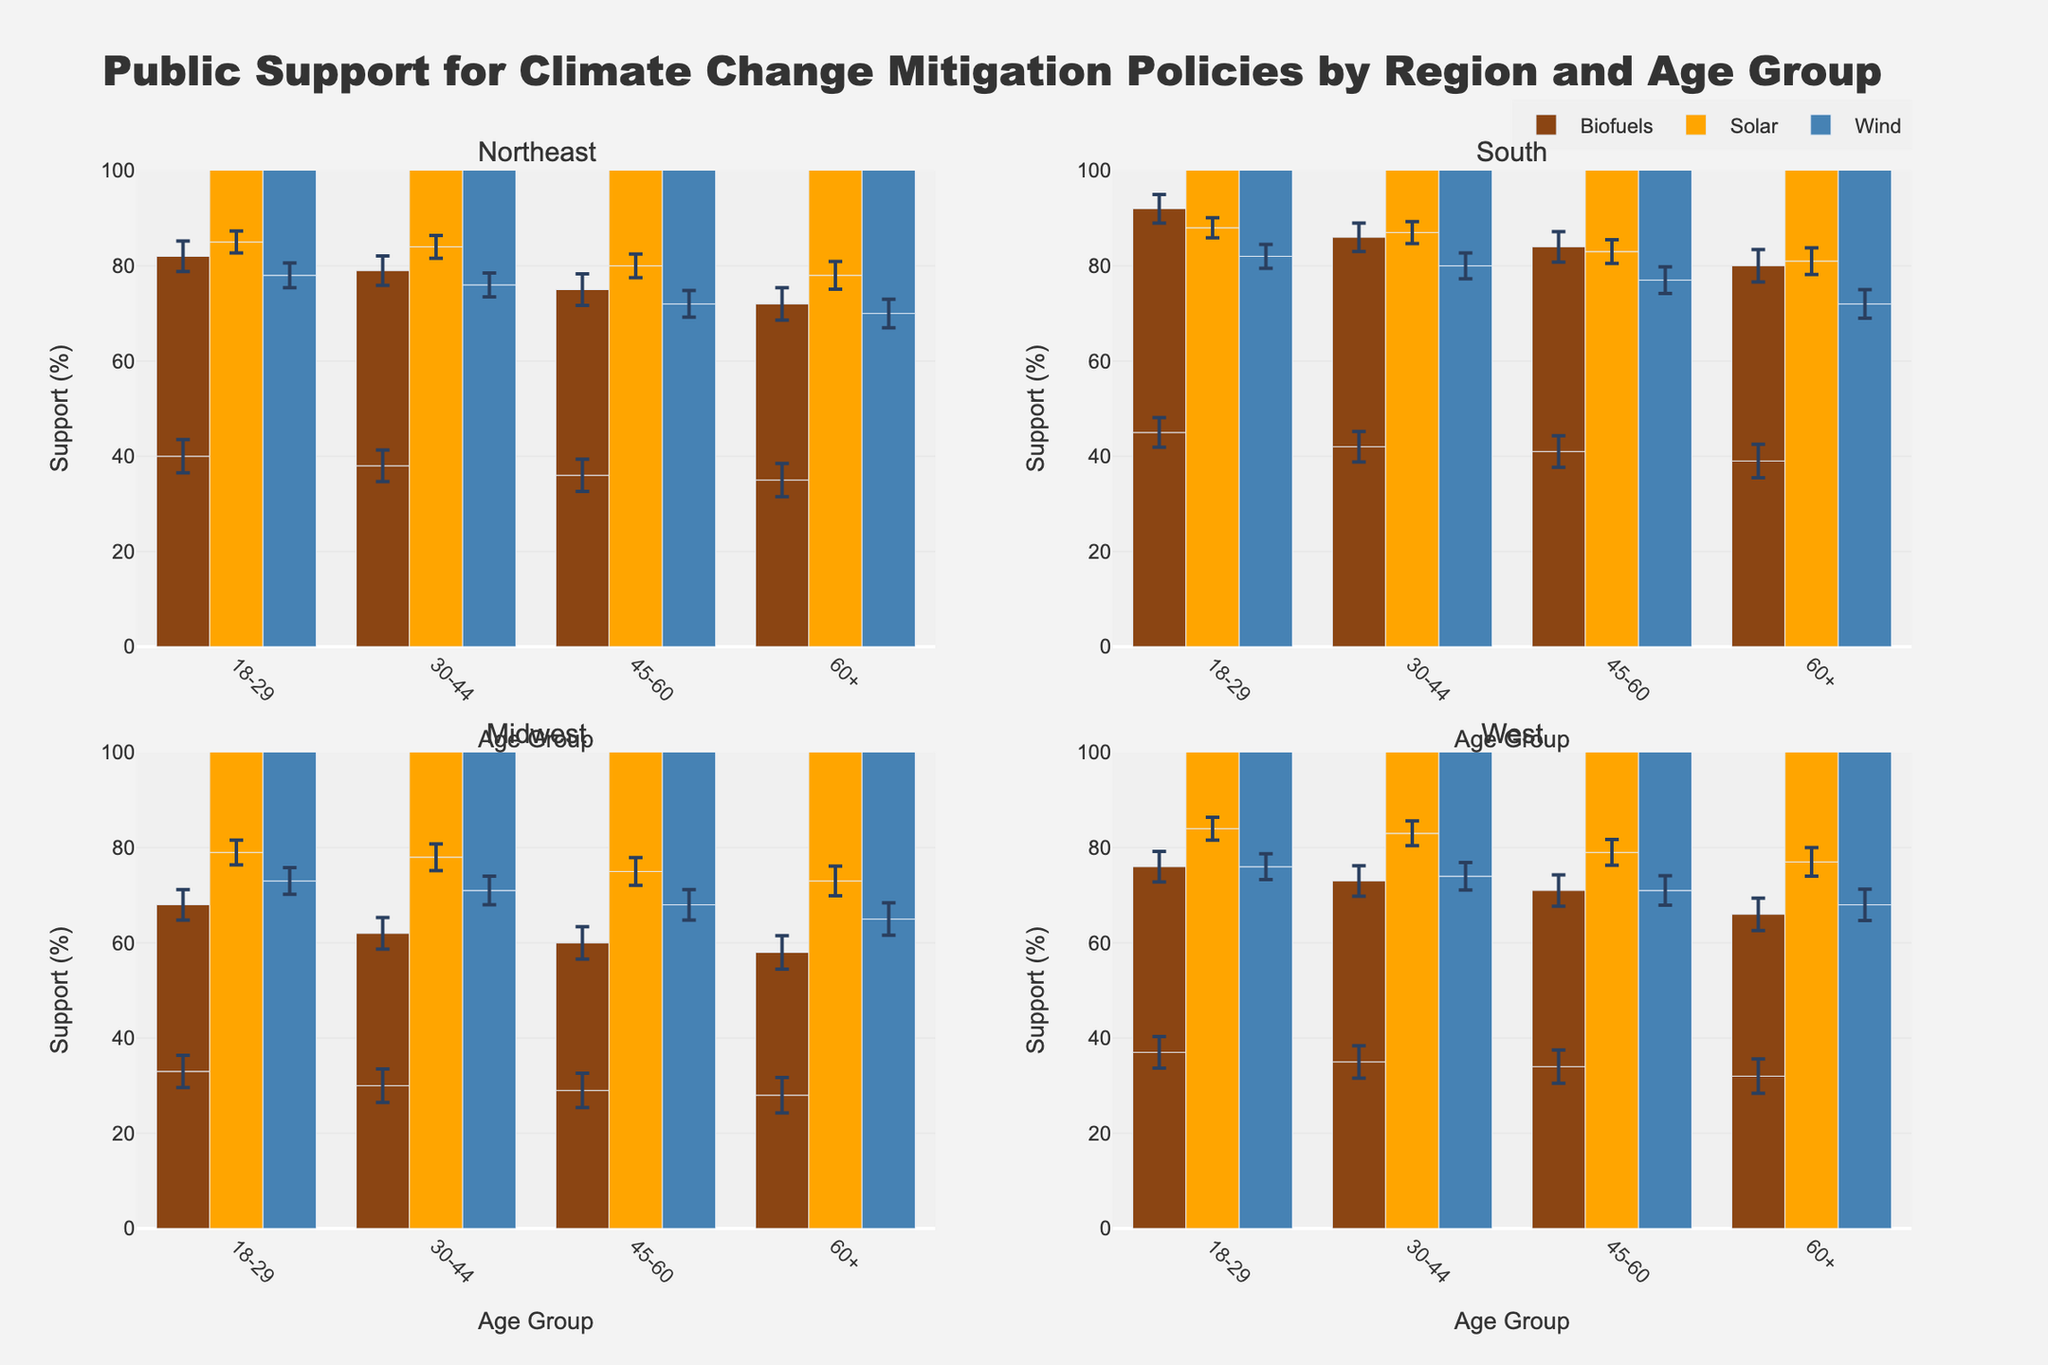How is support for biofuels among 18-29-year-old males in the South? Look at the subplot for the South region and check the bar representing biofuels for the 18-29 age group. The height of the bar will give the support percentage, and the error bar shows the standard error.
Answer: 45% Which region has the highest level of support for solar energy among 60+ females? Compare the heights of the solar support bars for 60+ females across all four subplots (Northeast, South, Midwest, West). The tallest bar indicates the highest support.
Answer: South What is the average support for wind energy across all age groups in the Midwest? Look at the subplot for the Midwest region, find the wind energy support percentages for all age categories, add them up, and divide by the number of age categories (5). Calculation: (73 + 72 + 71 + 68 + 66 + 65 + 63) / 7 = 68
Answer: 68 Which age group has the lowest support for biofuels in the Northeast? Look at the subplot for the Northeast region and compare the heights of the biofuels support bars across all age groups. The shortest bar indicates the lowest support percentage.
Answer: 60+ males Is there a noticeable difference in the support for solar energy between the 30-44 and 45-60 age groups in the West? Observe the solar energy support bars for both the 30-44 and 45-60 age groups in the West subplot. Compare their heights and the length of their error bars.
Answer: Minor difference, slightly higher for 30-44 What is the range of support for biofuels among different age groups in the West? In the West subplot, identify the highest and lowest percentages of support for biofuels and calculate the difference. Calculation: 39 (highest) - 32 (lowest) = 7
Answer: 7 Which gender shows the highest level of support for wind energy in the Northeast across all age groups? Focus on the wind energy support bars for both males and females across all age groups in the Northeast subplot. Compare the highest bars between genders.
Answer: Males (18-29 age group) What is the general trend in support for biofuels as age increases across all regions? Observe the biofuels support bars across all subplots (regions) and note the changes in bar heights from younger to older age groups.
Answer: Decreasing support with increasing age How does the error bar length for biofuels support compare between the Midwest and the Northeast for 45-60 females? Compare the length of the error bars on the biofuels support bars for 45-60 females in both the Midwest and Northeast subplots.
Answer: Similar length What are the consistent patterns across all regions for the support of solar energy? Compare the solar energy support bars across all age groups in all four subplots (regions) to identify repeating trends.
Answer: High support in all regions 